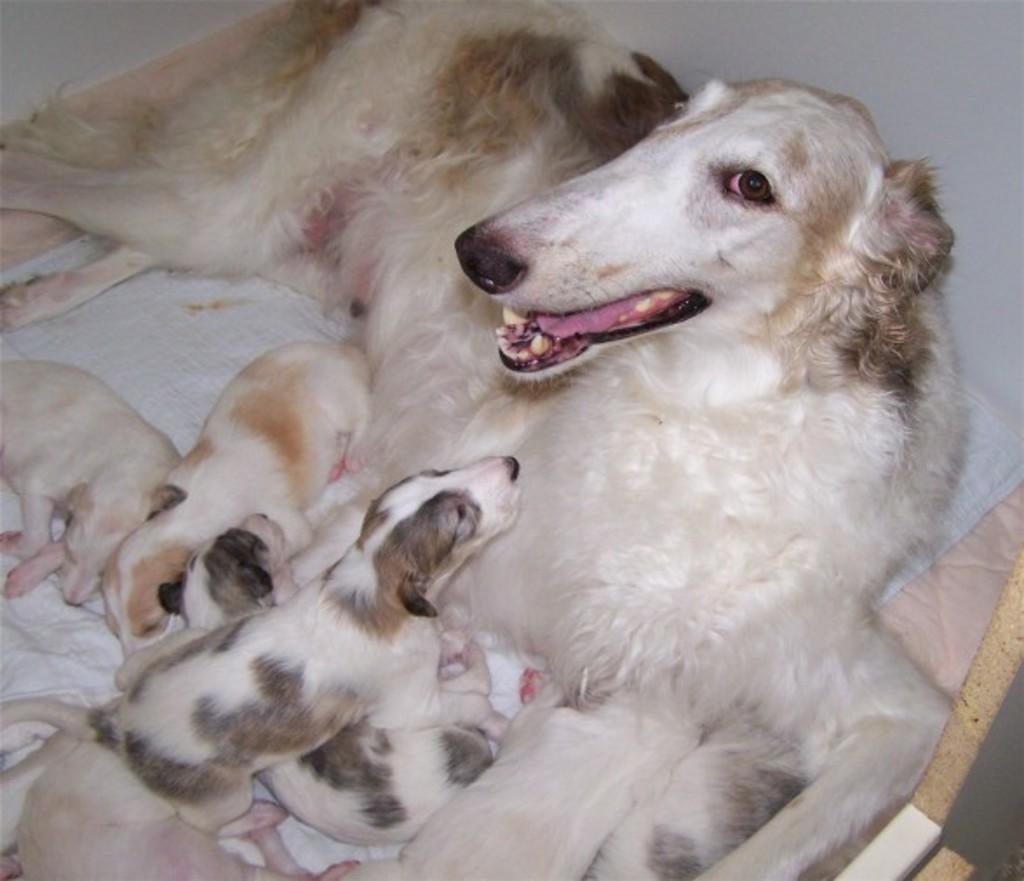What type of animals are in the image? There is a group of dogs in the image. Where are the dogs located? The dogs are on a dog bed. What can be seen in the background of the image? There is a wall in the background of the image. What arithmetic problem can be solved using the dogs in the image? There is no arithmetic problem present in the image, as it features a group of dogs on a dog bed with a wall in the background. 